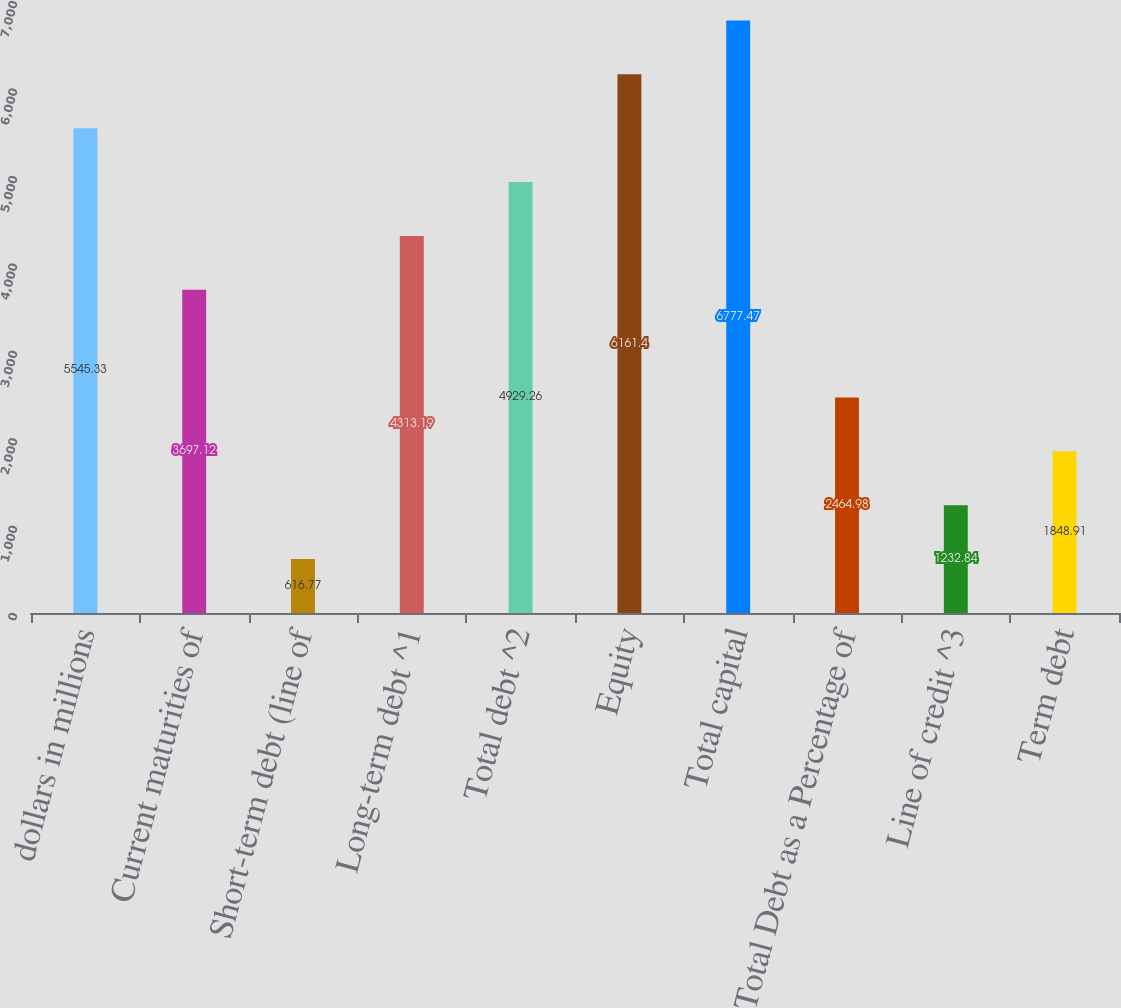Convert chart to OTSL. <chart><loc_0><loc_0><loc_500><loc_500><bar_chart><fcel>dollars in millions<fcel>Current maturities of<fcel>Short-term debt (line of<fcel>Long-term debt ^1<fcel>Total debt ^2<fcel>Equity<fcel>Total capital<fcel>Total Debt as a Percentage of<fcel>Line of credit ^3<fcel>Term debt<nl><fcel>5545.33<fcel>3697.12<fcel>616.77<fcel>4313.19<fcel>4929.26<fcel>6161.4<fcel>6777.47<fcel>2464.98<fcel>1232.84<fcel>1848.91<nl></chart> 